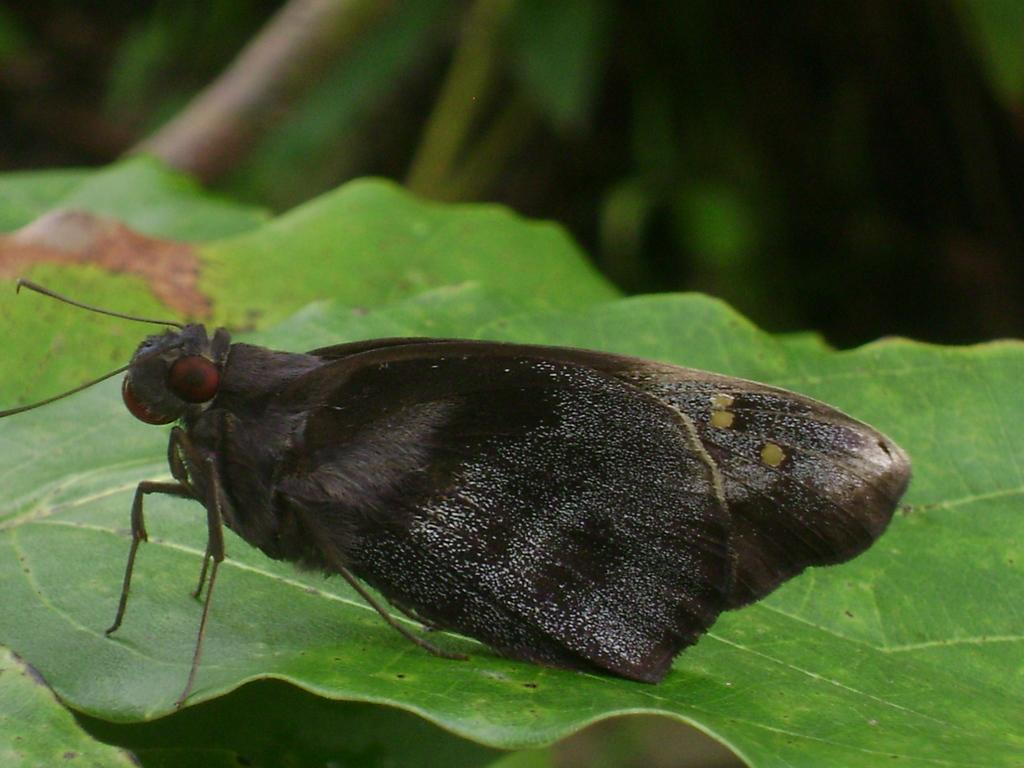What is present on the leaf in the image? There is an insect on a leaf in the image. Can you describe the background of the image? The background of the image is blurry. What type of knife is being used to copy notes in the image? There is no knife or notebook present in the image; it only features an insect on a leaf with a blurry background. 